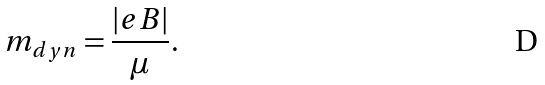<formula> <loc_0><loc_0><loc_500><loc_500>m _ { d y n } = \frac { | e B | } { \mu } .</formula> 